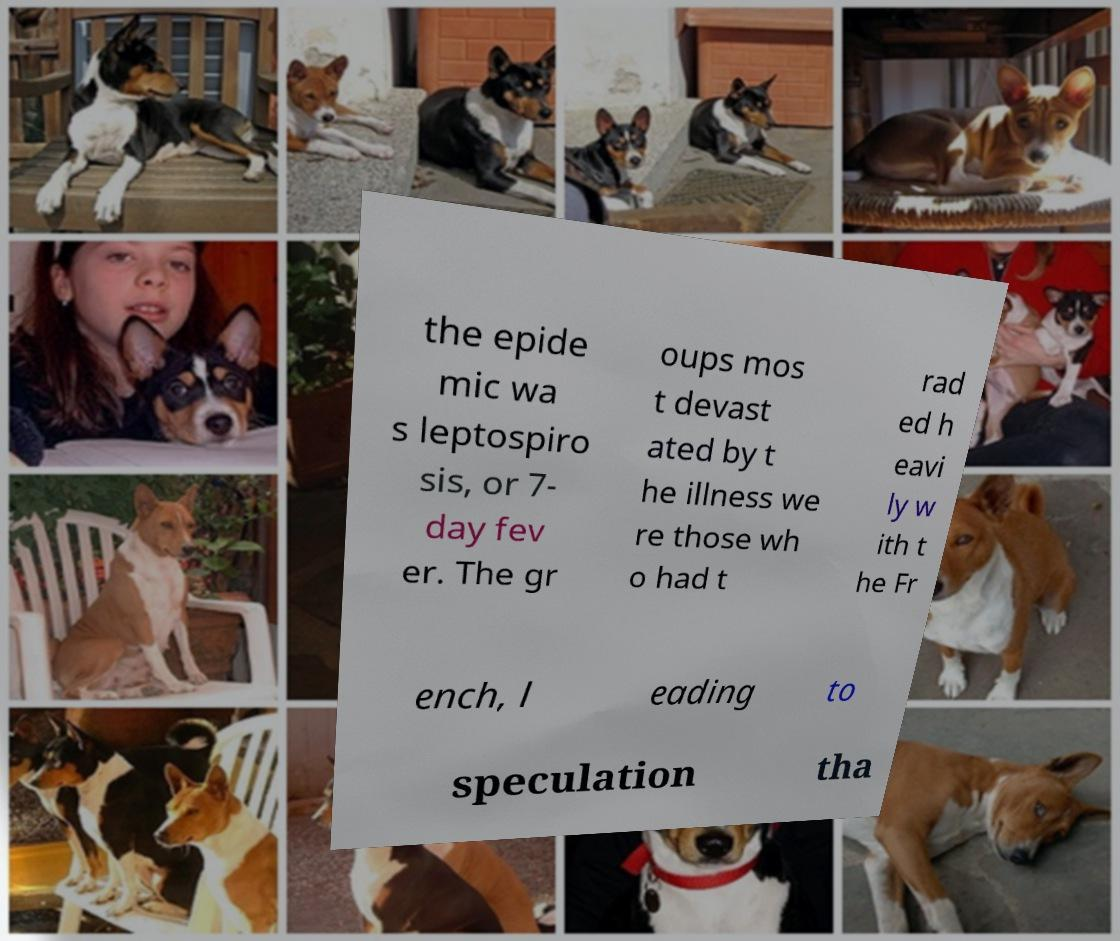Can you read and provide the text displayed in the image?This photo seems to have some interesting text. Can you extract and type it out for me? the epide mic wa s leptospiro sis, or 7- day fev er. The gr oups mos t devast ated by t he illness we re those wh o had t rad ed h eavi ly w ith t he Fr ench, l eading to speculation tha 